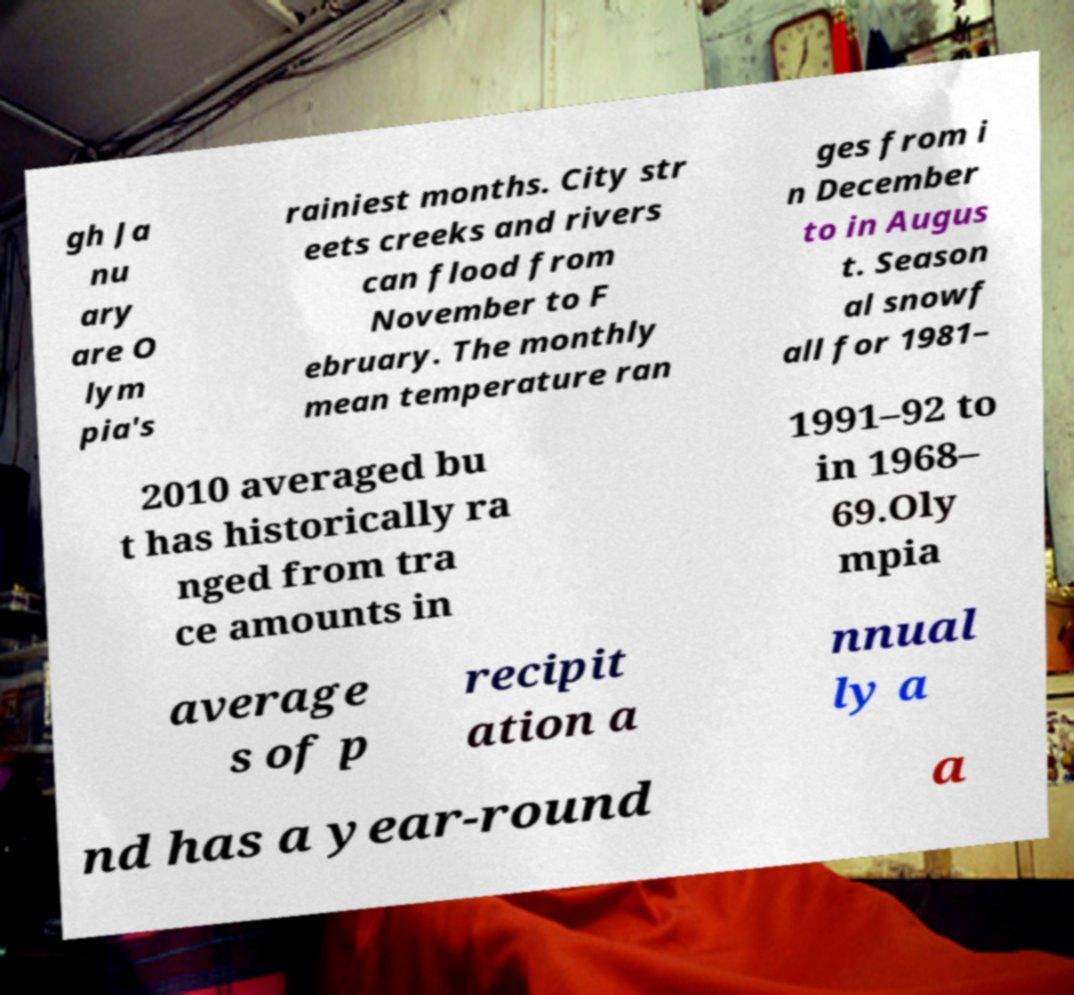For documentation purposes, I need the text within this image transcribed. Could you provide that? gh Ja nu ary are O lym pia's rainiest months. City str eets creeks and rivers can flood from November to F ebruary. The monthly mean temperature ran ges from i n December to in Augus t. Season al snowf all for 1981– 2010 averaged bu t has historically ra nged from tra ce amounts in 1991–92 to in 1968– 69.Oly mpia average s of p recipit ation a nnual ly a nd has a year-round a 